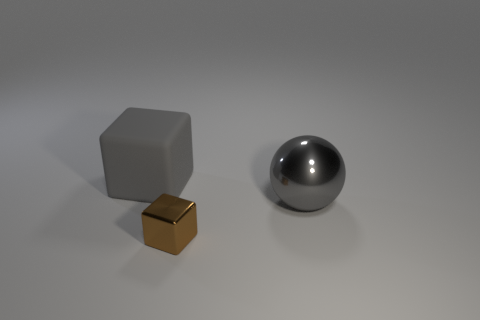Subtract all green spheres. Subtract all green cylinders. How many spheres are left? 1 Subtract all red cylinders. How many brown blocks are left? 1 Subtract all big blocks. Subtract all big yellow metallic blocks. How many objects are left? 2 Add 2 big gray objects. How many big gray objects are left? 4 Add 2 tiny blue metal objects. How many tiny blue metal objects exist? 2 Add 1 gray matte blocks. How many objects exist? 4 Subtract all gray blocks. How many blocks are left? 1 Subtract 0 yellow blocks. How many objects are left? 3 Subtract all cubes. How many objects are left? 1 Subtract 1 balls. How many balls are left? 0 